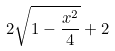Convert formula to latex. <formula><loc_0><loc_0><loc_500><loc_500>2 \sqrt { 1 - \frac { x ^ { 2 } } { 4 } } + 2</formula> 